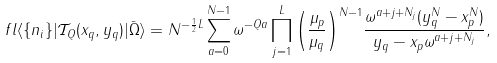Convert formula to latex. <formula><loc_0><loc_0><loc_500><loc_500>\ f l \langle \{ n _ { i } \} | \mathcal { T } _ { Q } ( x _ { q } , y _ { q } ) | { \bar { \Omega } } \rangle = N ^ { - { \frac { 1 } { 2 } } L } \sum _ { a = 0 } ^ { N - 1 } \omega ^ { - Q a } \prod _ { j = 1 } ^ { L } { \left ( \frac { \mu _ { p } } { \mu _ { q } } \right ) } ^ { N - 1 } \frac { \omega ^ { a + j + N _ { j } } ( y _ { q } ^ { N } - x _ { p } ^ { N } ) } { y _ { q } - x _ { p } \omega ^ { a + j + N _ { j } } } ,</formula> 